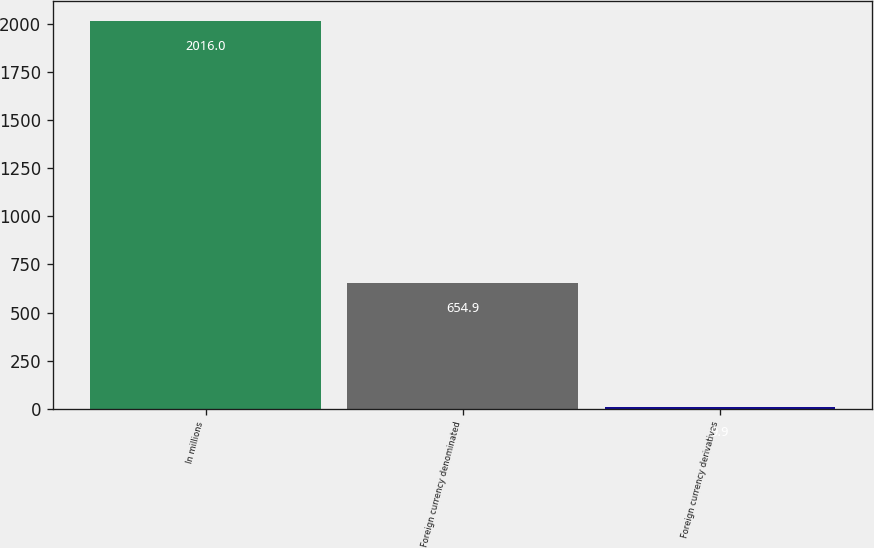Convert chart to OTSL. <chart><loc_0><loc_0><loc_500><loc_500><bar_chart><fcel>In millions<fcel>Foreign currency denominated<fcel>Foreign currency derivatives<nl><fcel>2016<fcel>654.9<fcel>9.9<nl></chart> 